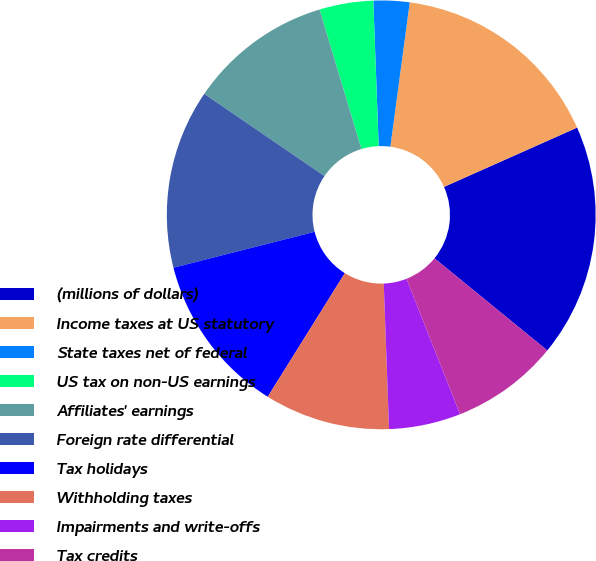<chart> <loc_0><loc_0><loc_500><loc_500><pie_chart><fcel>(millions of dollars)<fcel>Income taxes at US statutory<fcel>State taxes net of federal<fcel>US tax on non-US earnings<fcel>Affiliates' earnings<fcel>Foreign rate differential<fcel>Tax holidays<fcel>Withholding taxes<fcel>Impairments and write-offs<fcel>Tax credits<nl><fcel>17.57%<fcel>16.21%<fcel>2.71%<fcel>4.06%<fcel>10.81%<fcel>13.51%<fcel>12.16%<fcel>9.46%<fcel>5.41%<fcel>8.11%<nl></chart> 